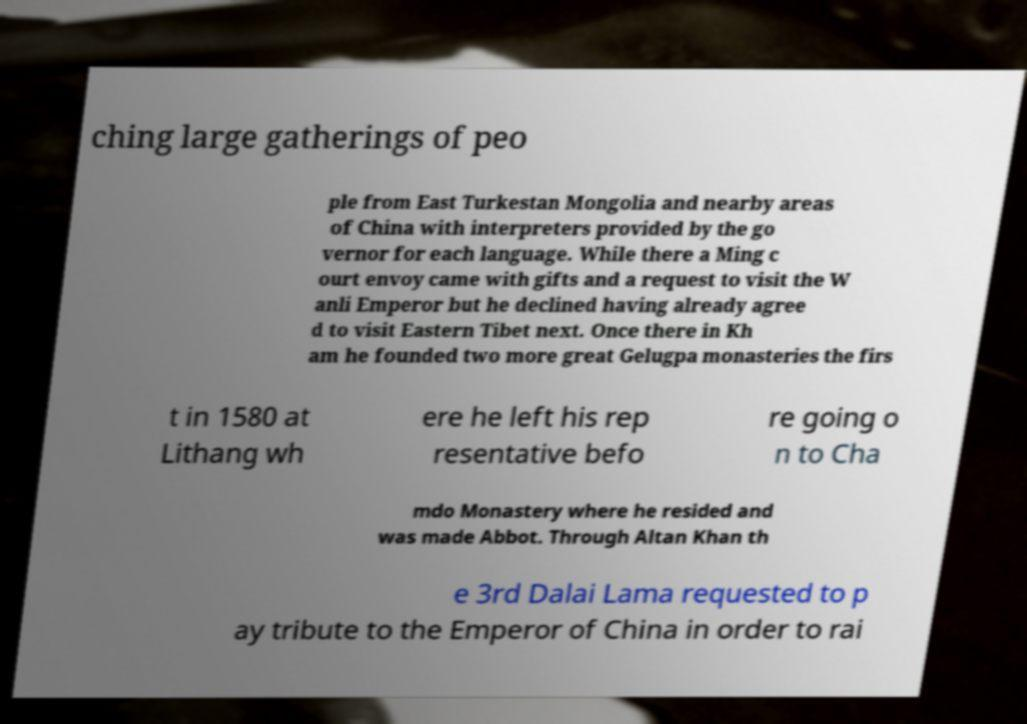Could you assist in decoding the text presented in this image and type it out clearly? ching large gatherings of peo ple from East Turkestan Mongolia and nearby areas of China with interpreters provided by the go vernor for each language. While there a Ming c ourt envoy came with gifts and a request to visit the W anli Emperor but he declined having already agree d to visit Eastern Tibet next. Once there in Kh am he founded two more great Gelugpa monasteries the firs t in 1580 at Lithang wh ere he left his rep resentative befo re going o n to Cha mdo Monastery where he resided and was made Abbot. Through Altan Khan th e 3rd Dalai Lama requested to p ay tribute to the Emperor of China in order to rai 